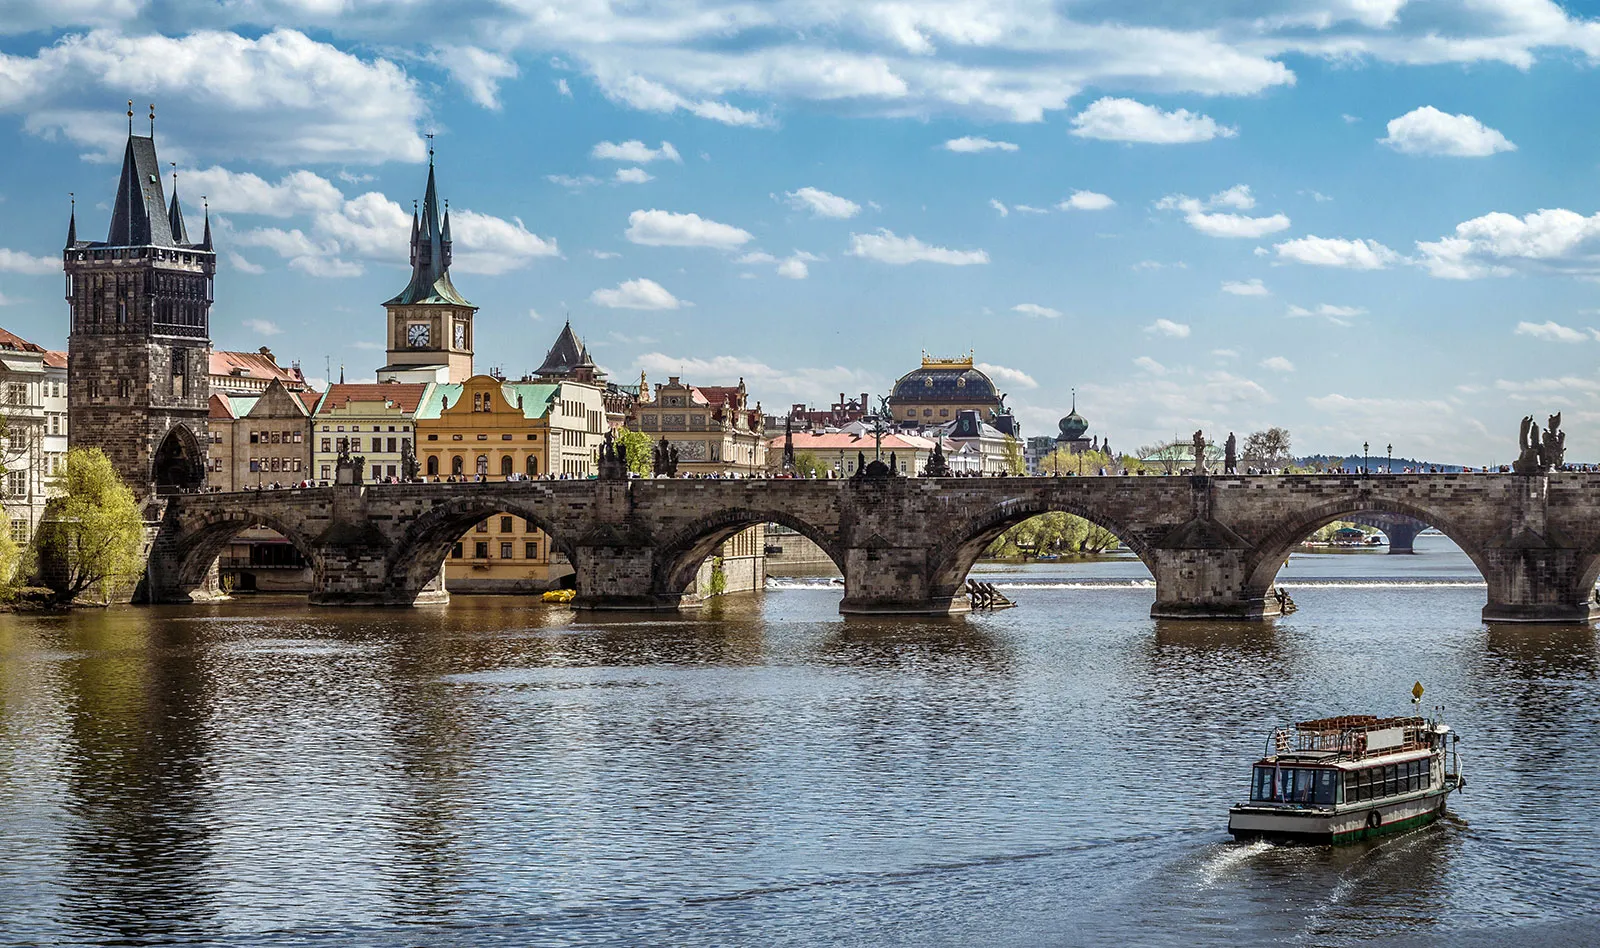Can you tell me more about the architectural style and details of Charles Bridge? Absolutely! Charles Bridge is a fine example of Gothic architecture, designed by the architect Petr Parléř. Its construction features characteristic pointed arches and a use of heavy, dark stone. It spans 621 meters and holds 30 statues mostly baroque style added during the 17th and 18th centuries, which depict various saints and patron figures revered at the time. 